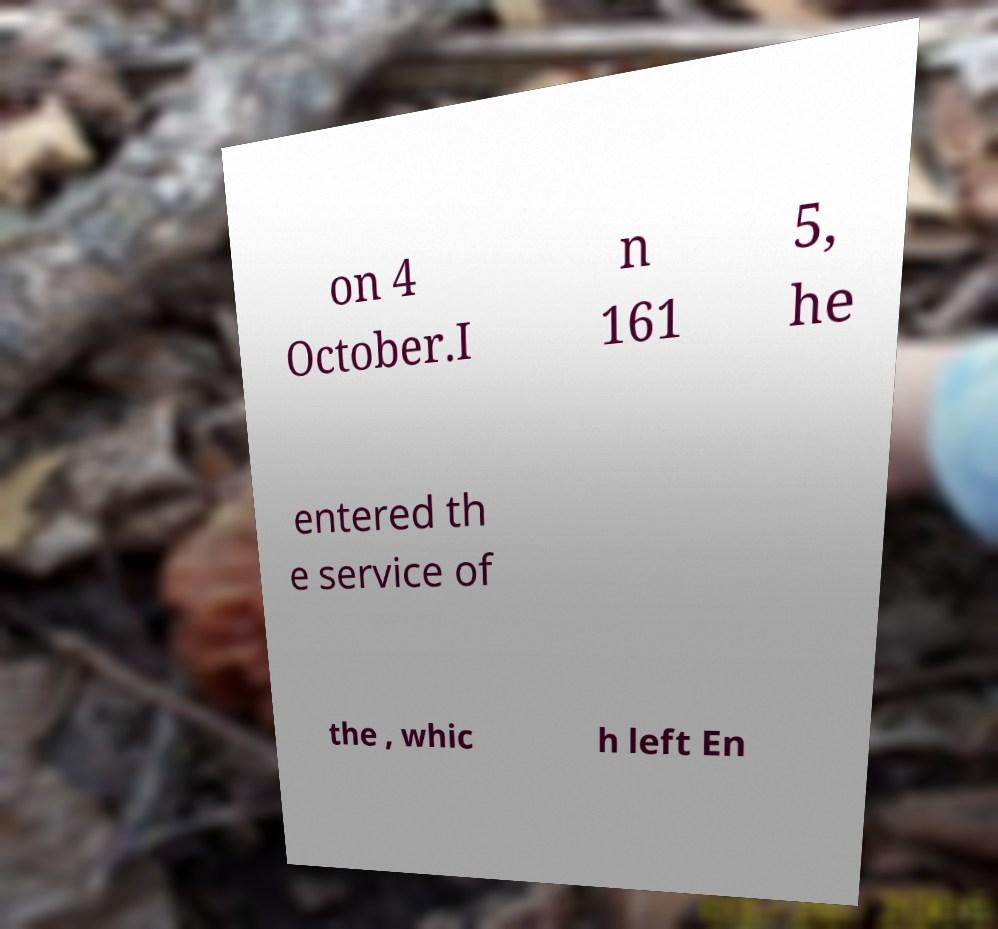Can you accurately transcribe the text from the provided image for me? on 4 October.I n 161 5, he entered th e service of the , whic h left En 